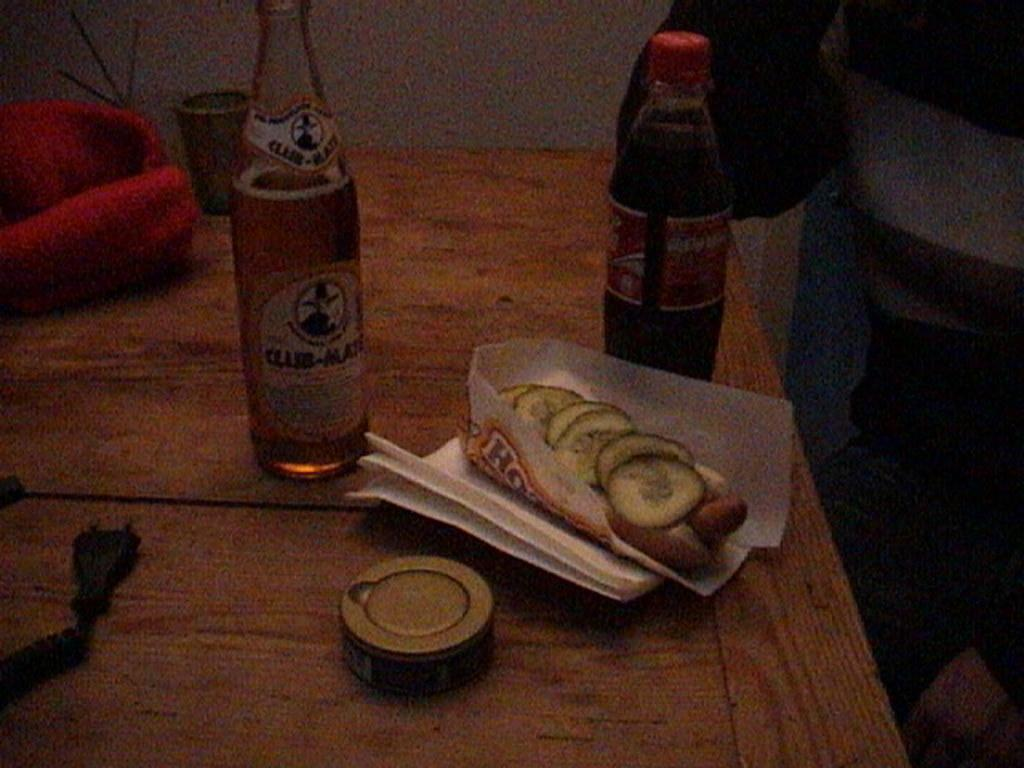What type of bottle is visible in the image? There is a wine bottle in the image. Are there any other bottles present in the image? Yes, there is another bottle in the image. What type of snack is present in the image? There are chips in a paper in the image. What other objects can be seen in the image? There is a box, a pouch, and a glass in the image. Where are these objects located? The objects are arranged on a table in the image. What can be seen in the background of the image? There is a wall visible in the background of the image. Can you tell me how many umbrellas are open in the image? There are no umbrellas present in the image. What shape is the square in the image? There is no square present in the image. 